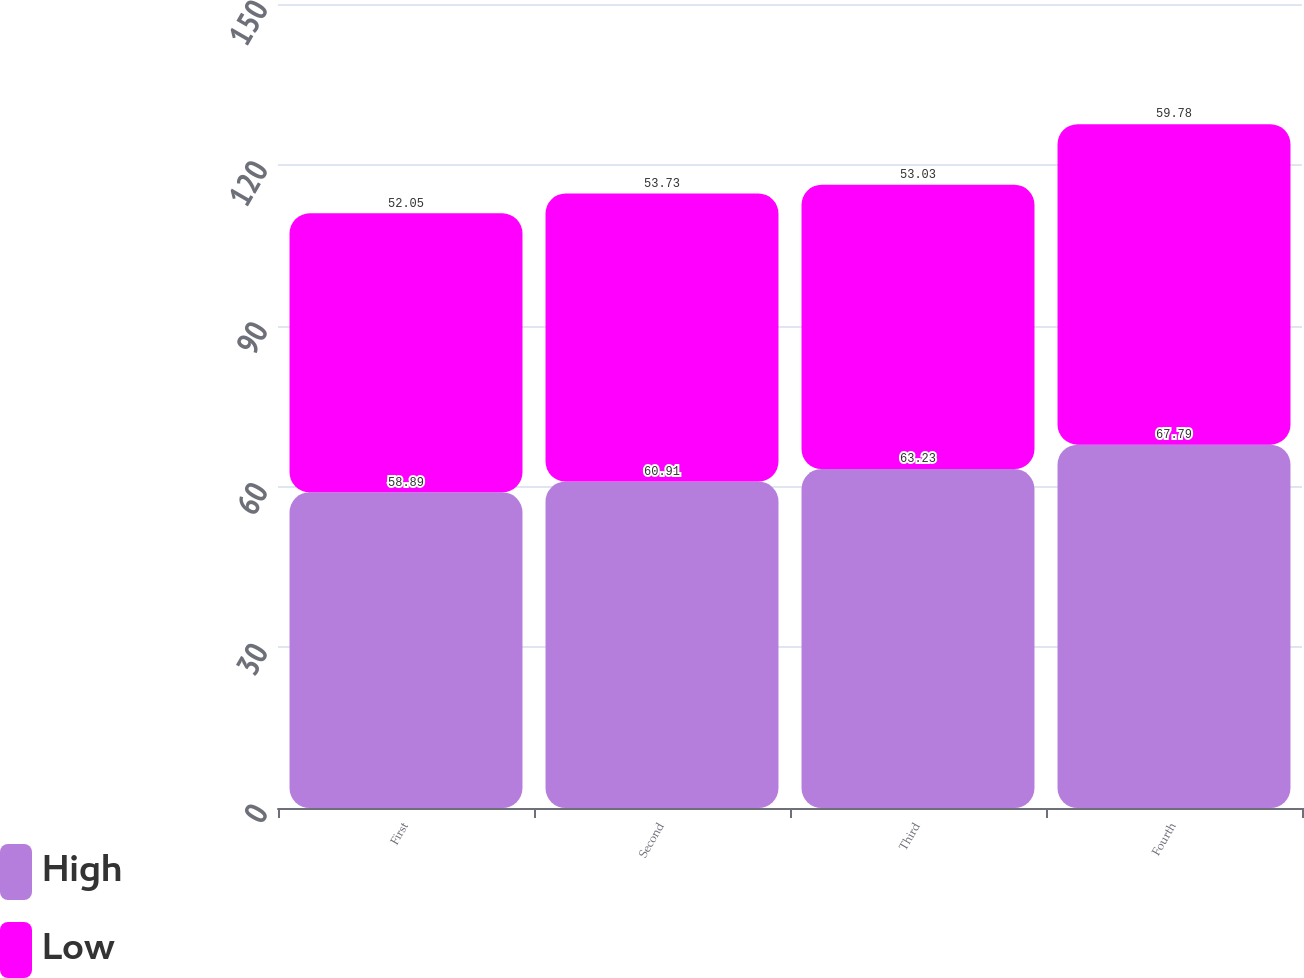Convert chart to OTSL. <chart><loc_0><loc_0><loc_500><loc_500><stacked_bar_chart><ecel><fcel>First<fcel>Second<fcel>Third<fcel>Fourth<nl><fcel>High<fcel>58.89<fcel>60.91<fcel>63.23<fcel>67.79<nl><fcel>Low<fcel>52.05<fcel>53.73<fcel>53.03<fcel>59.78<nl></chart> 